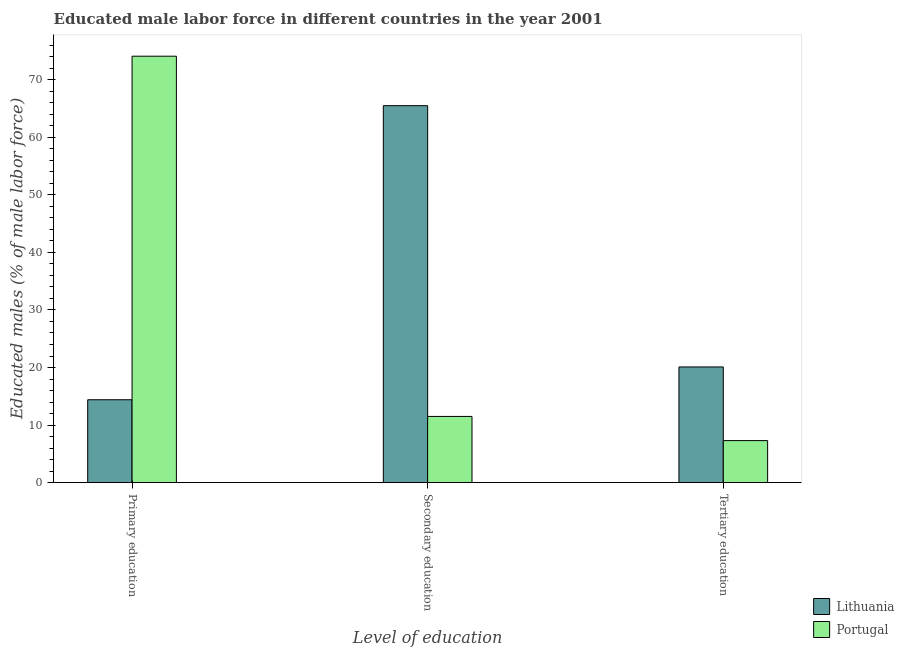How many different coloured bars are there?
Ensure brevity in your answer.  2. Are the number of bars per tick equal to the number of legend labels?
Your answer should be very brief. Yes. Are the number of bars on each tick of the X-axis equal?
Your response must be concise. Yes. How many bars are there on the 3rd tick from the right?
Your answer should be compact. 2. What is the label of the 3rd group of bars from the left?
Your answer should be very brief. Tertiary education. What is the percentage of male labor force who received secondary education in Lithuania?
Keep it short and to the point. 65.5. Across all countries, what is the maximum percentage of male labor force who received secondary education?
Give a very brief answer. 65.5. Across all countries, what is the minimum percentage of male labor force who received secondary education?
Provide a short and direct response. 11.5. In which country was the percentage of male labor force who received secondary education maximum?
Offer a terse response. Lithuania. In which country was the percentage of male labor force who received primary education minimum?
Ensure brevity in your answer.  Lithuania. What is the difference between the percentage of male labor force who received tertiary education in Lithuania and that in Portugal?
Make the answer very short. 12.8. What is the difference between the percentage of male labor force who received tertiary education in Lithuania and the percentage of male labor force who received primary education in Portugal?
Ensure brevity in your answer.  -54. What is the average percentage of male labor force who received secondary education per country?
Provide a succinct answer. 38.5. What is the difference between the percentage of male labor force who received primary education and percentage of male labor force who received secondary education in Portugal?
Make the answer very short. 62.6. What is the ratio of the percentage of male labor force who received secondary education in Portugal to that in Lithuania?
Ensure brevity in your answer.  0.18. Is the percentage of male labor force who received primary education in Portugal less than that in Lithuania?
Your answer should be very brief. No. Is the difference between the percentage of male labor force who received primary education in Portugal and Lithuania greater than the difference between the percentage of male labor force who received secondary education in Portugal and Lithuania?
Your response must be concise. Yes. What is the difference between the highest and the second highest percentage of male labor force who received primary education?
Your answer should be compact. 59.7. In how many countries, is the percentage of male labor force who received primary education greater than the average percentage of male labor force who received primary education taken over all countries?
Provide a succinct answer. 1. Is the sum of the percentage of male labor force who received tertiary education in Lithuania and Portugal greater than the maximum percentage of male labor force who received primary education across all countries?
Provide a succinct answer. No. What does the 1st bar from the right in Tertiary education represents?
Offer a very short reply. Portugal. Are all the bars in the graph horizontal?
Provide a short and direct response. No. Does the graph contain grids?
Provide a short and direct response. No. Where does the legend appear in the graph?
Make the answer very short. Bottom right. What is the title of the graph?
Your answer should be compact. Educated male labor force in different countries in the year 2001. Does "South Asia" appear as one of the legend labels in the graph?
Keep it short and to the point. No. What is the label or title of the X-axis?
Provide a short and direct response. Level of education. What is the label or title of the Y-axis?
Ensure brevity in your answer.  Educated males (% of male labor force). What is the Educated males (% of male labor force) of Lithuania in Primary education?
Ensure brevity in your answer.  14.4. What is the Educated males (% of male labor force) of Portugal in Primary education?
Give a very brief answer. 74.1. What is the Educated males (% of male labor force) of Lithuania in Secondary education?
Ensure brevity in your answer.  65.5. What is the Educated males (% of male labor force) in Portugal in Secondary education?
Offer a terse response. 11.5. What is the Educated males (% of male labor force) in Lithuania in Tertiary education?
Provide a succinct answer. 20.1. What is the Educated males (% of male labor force) in Portugal in Tertiary education?
Provide a short and direct response. 7.3. Across all Level of education, what is the maximum Educated males (% of male labor force) of Lithuania?
Make the answer very short. 65.5. Across all Level of education, what is the maximum Educated males (% of male labor force) in Portugal?
Ensure brevity in your answer.  74.1. Across all Level of education, what is the minimum Educated males (% of male labor force) in Lithuania?
Your response must be concise. 14.4. Across all Level of education, what is the minimum Educated males (% of male labor force) in Portugal?
Provide a succinct answer. 7.3. What is the total Educated males (% of male labor force) of Lithuania in the graph?
Your answer should be compact. 100. What is the total Educated males (% of male labor force) in Portugal in the graph?
Your response must be concise. 92.9. What is the difference between the Educated males (% of male labor force) in Lithuania in Primary education and that in Secondary education?
Keep it short and to the point. -51.1. What is the difference between the Educated males (% of male labor force) in Portugal in Primary education and that in Secondary education?
Make the answer very short. 62.6. What is the difference between the Educated males (% of male labor force) of Lithuania in Primary education and that in Tertiary education?
Your answer should be very brief. -5.7. What is the difference between the Educated males (% of male labor force) in Portugal in Primary education and that in Tertiary education?
Your answer should be compact. 66.8. What is the difference between the Educated males (% of male labor force) of Lithuania in Secondary education and that in Tertiary education?
Your answer should be very brief. 45.4. What is the difference between the Educated males (% of male labor force) in Lithuania in Primary education and the Educated males (% of male labor force) in Portugal in Tertiary education?
Your answer should be very brief. 7.1. What is the difference between the Educated males (% of male labor force) in Lithuania in Secondary education and the Educated males (% of male labor force) in Portugal in Tertiary education?
Give a very brief answer. 58.2. What is the average Educated males (% of male labor force) of Lithuania per Level of education?
Keep it short and to the point. 33.33. What is the average Educated males (% of male labor force) of Portugal per Level of education?
Ensure brevity in your answer.  30.97. What is the difference between the Educated males (% of male labor force) of Lithuania and Educated males (% of male labor force) of Portugal in Primary education?
Ensure brevity in your answer.  -59.7. What is the ratio of the Educated males (% of male labor force) in Lithuania in Primary education to that in Secondary education?
Offer a very short reply. 0.22. What is the ratio of the Educated males (% of male labor force) in Portugal in Primary education to that in Secondary education?
Your response must be concise. 6.44. What is the ratio of the Educated males (% of male labor force) in Lithuania in Primary education to that in Tertiary education?
Provide a short and direct response. 0.72. What is the ratio of the Educated males (% of male labor force) of Portugal in Primary education to that in Tertiary education?
Your answer should be very brief. 10.15. What is the ratio of the Educated males (% of male labor force) of Lithuania in Secondary education to that in Tertiary education?
Make the answer very short. 3.26. What is the ratio of the Educated males (% of male labor force) of Portugal in Secondary education to that in Tertiary education?
Provide a short and direct response. 1.58. What is the difference between the highest and the second highest Educated males (% of male labor force) in Lithuania?
Provide a succinct answer. 45.4. What is the difference between the highest and the second highest Educated males (% of male labor force) of Portugal?
Offer a terse response. 62.6. What is the difference between the highest and the lowest Educated males (% of male labor force) of Lithuania?
Provide a succinct answer. 51.1. What is the difference between the highest and the lowest Educated males (% of male labor force) of Portugal?
Ensure brevity in your answer.  66.8. 